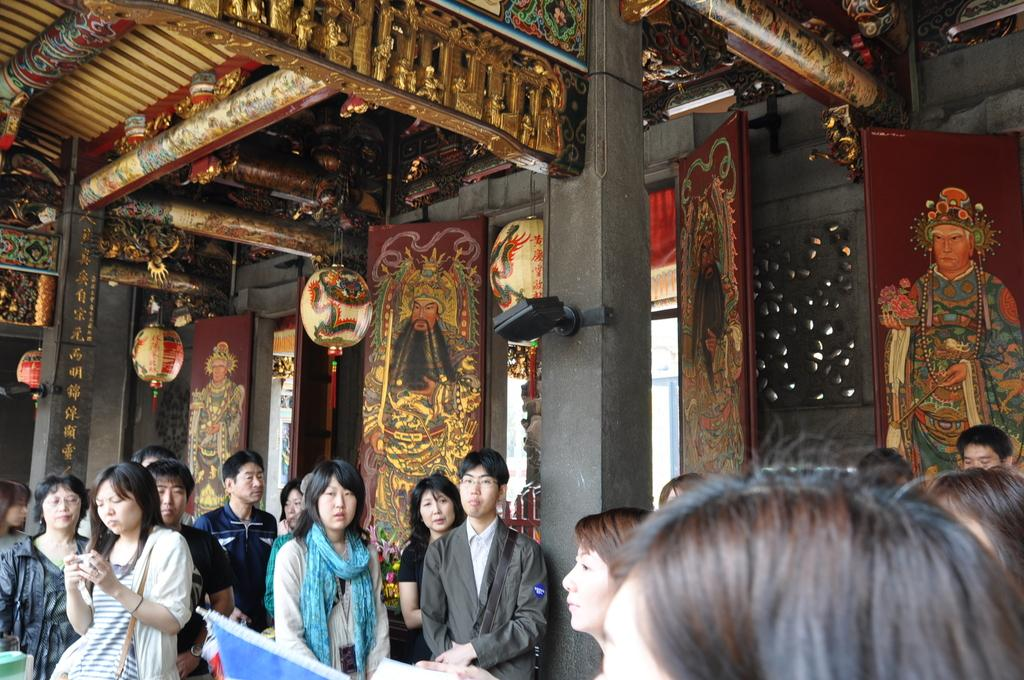What type of building is in the image? There is a Buddhist temple in the image. What feature can be seen on the temple? The temple has golden photo frames. Who is present in the image? There is a group of men and women standing in front of the temple. What are the people in the image doing? The group is looking at the camera. What type of cork can be seen in the image? There is no cork present in the image. How do the people in the image answer the questions asked by the photographer? The image does not show the people answering any questions, as they are simply looking at the camera. 